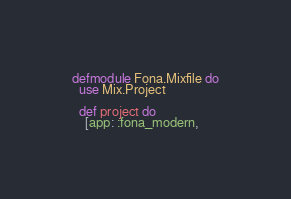<code> <loc_0><loc_0><loc_500><loc_500><_Elixir_>defmodule Fona.Mixfile do
  use Mix.Project

  def project do
    [app: :fona_modern,</code> 